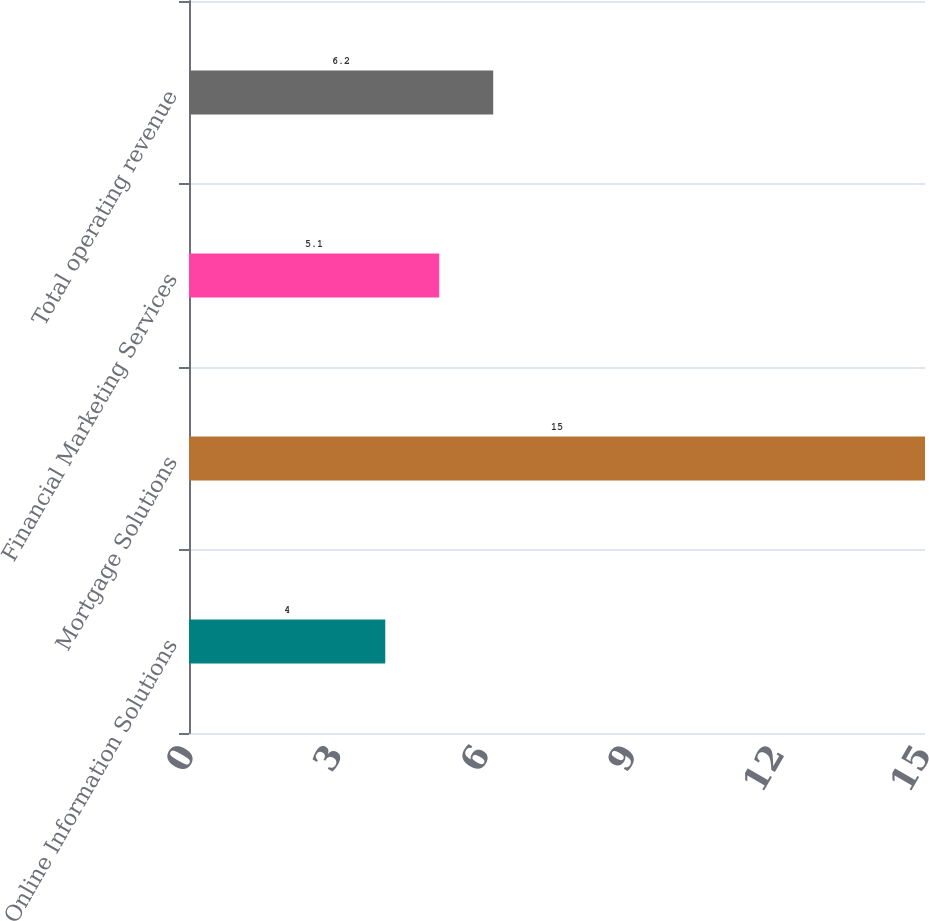Convert chart to OTSL. <chart><loc_0><loc_0><loc_500><loc_500><bar_chart><fcel>Online Information Solutions<fcel>Mortgage Solutions<fcel>Financial Marketing Services<fcel>Total operating revenue<nl><fcel>4<fcel>15<fcel>5.1<fcel>6.2<nl></chart> 